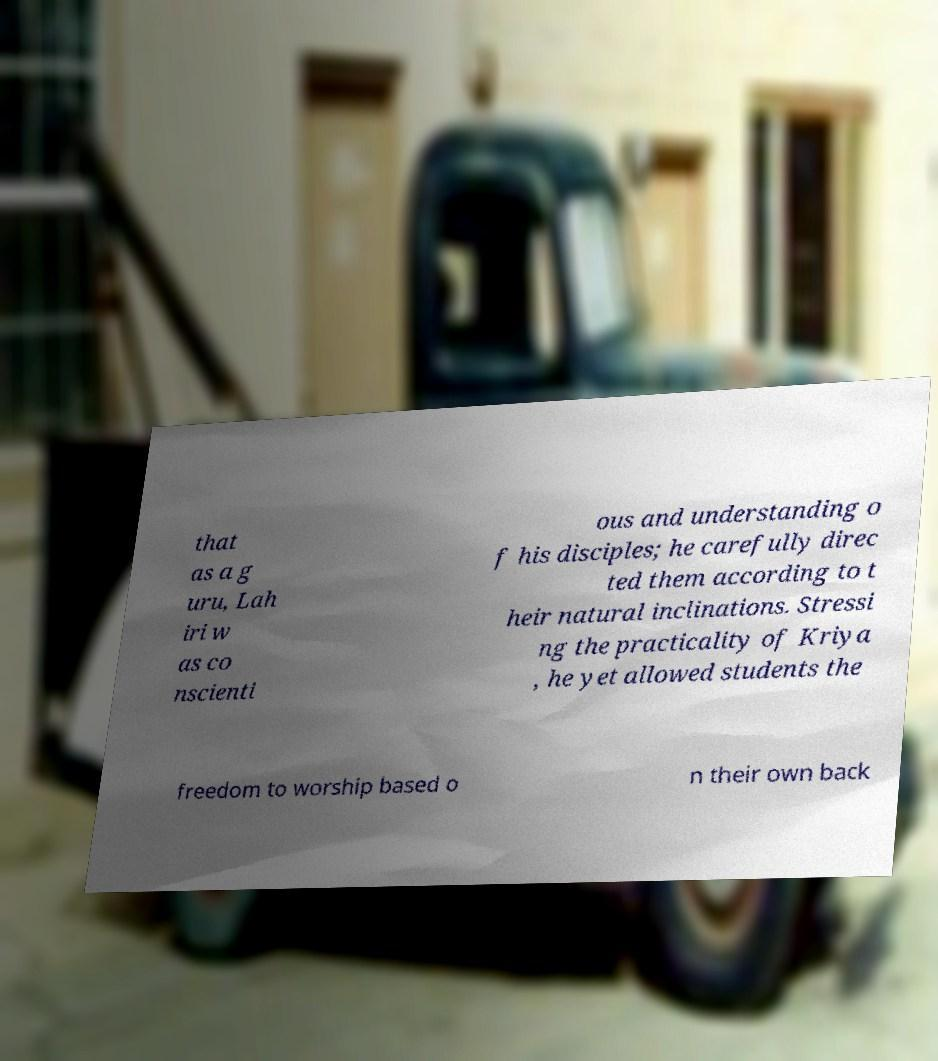Can you accurately transcribe the text from the provided image for me? that as a g uru, Lah iri w as co nscienti ous and understanding o f his disciples; he carefully direc ted them according to t heir natural inclinations. Stressi ng the practicality of Kriya , he yet allowed students the freedom to worship based o n their own back 